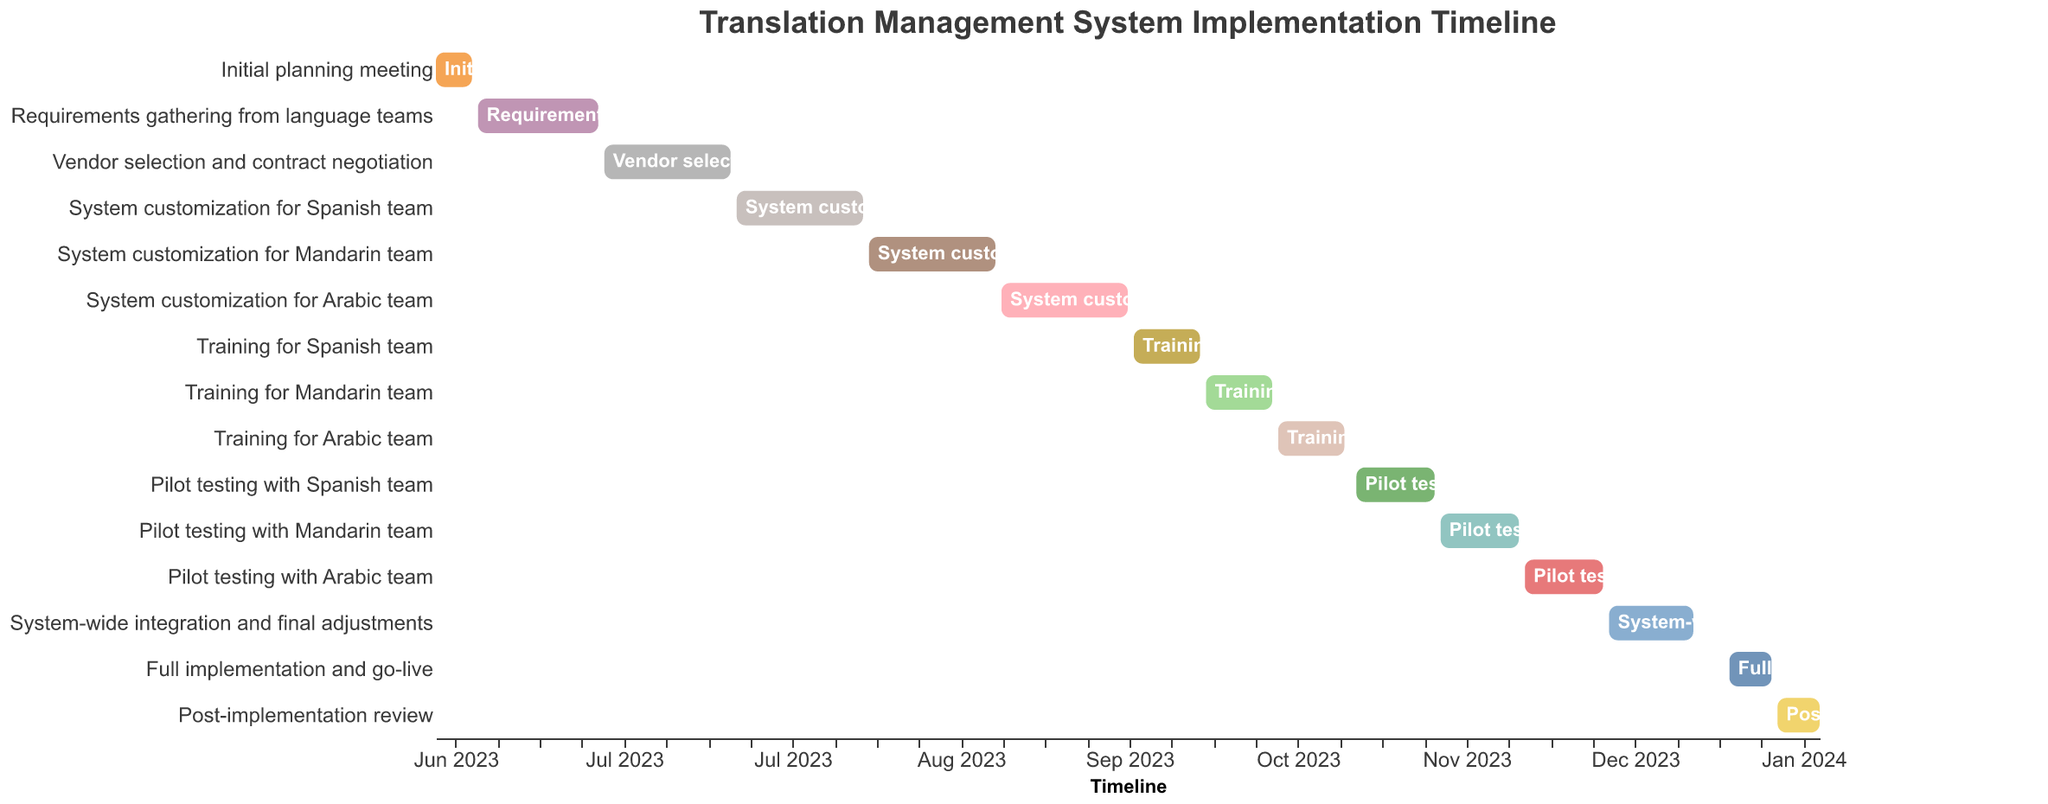What's the title of the Gantt Chart? The title is clearly displayed at the top of the chart and reads "Translation Management System Implementation Timeline".
Answer: Translation Management System Implementation Timeline When does the "System customization for Spanish team" task start and end? By examining the corresponding bar for the "System customization for Spanish team" on the y-axis and reading its boundaries along the x-axis, we see it starts on July 21, 2023, and ends on August 11, 2023.
Answer: July 21, 2023, to August 11, 2023 How long is the "Training for the Mandarin team" task? The "Training for Mandarin team" task's start and end dates are from October 7, 2023, to October 18, 2023. The duration can be calculated by counting the days between these two dates, inclusive. October 18 - October 7 = 11 days.
Answer: 11 days Compare the duration of "Vendor selection and contract negotiation" with "Post-implementation review". Which one is longer and by how many days? "Vendor selection and contract negotiation" runs from June 29, 2023, to July 20, 2023, which is 22 days long. "Post-implementation review" is from January 10, 2024, to January 17, 2024, which is 8 days long. Thus, "Vendor selection and contract negotiation" is longer by 22 - 8 = 14 days.
Answer: Vendor selection and contract negotiation is longer by 14 days What are the consecutive tasks after the "Pilot testing with Arabic team" ends? Follow the timeline from the end of "Pilot testing with Arabic team" on December 12, 2023. The next task after this is "System-wide integration and final adjustments" starting December 13, 2023, followed by "Full implementation and go-live" starting January 2, 2024.
Answer: System-wide integration and final adjustments, Full implementation and go-live What's the duration of the entire implementation process from the first task to the last task? The timeline spans from the "Initial planning meeting" starting on June 1, 2023, to the end of the "Post-implementation review" on January 17, 2024. The total duration can be calculated by counting the days from June 1, 2023, to January 17, 2024. This is approximately 230 days.
Answer: 230 days Which customization task comes immediately after the "System customization for Spanish team"? Observing the timeline sequence, immediately after the "System customization for Spanish team", the "System customization for Mandarin team" begins on August 12, 2023.
Answer: System customization for Mandarin team 